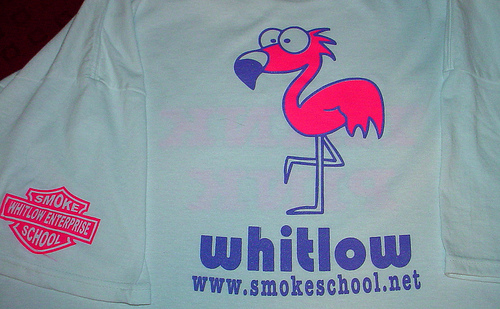<image>
Can you confirm if the flamingo is to the left of the purple words? No. The flamingo is not to the left of the purple words. From this viewpoint, they have a different horizontal relationship. 